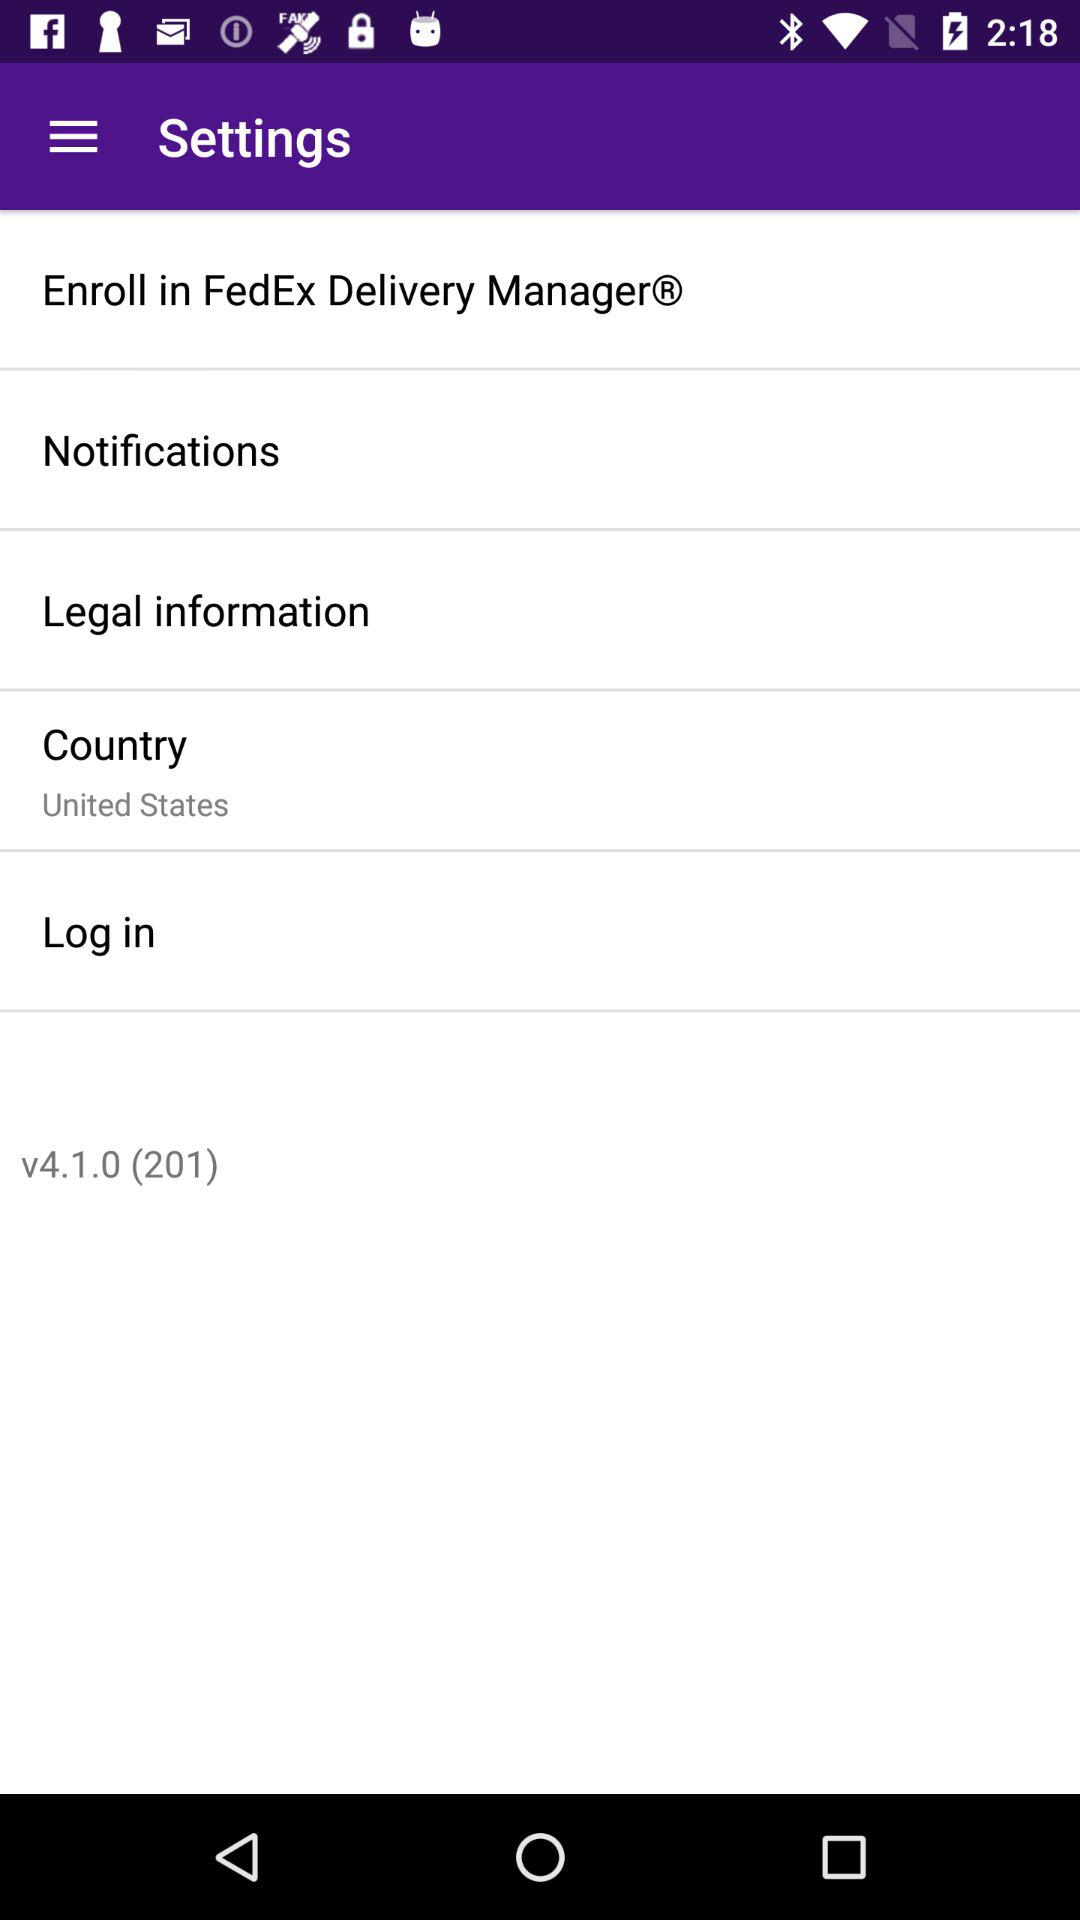What version is it? The version is v4.1.0 (201). 